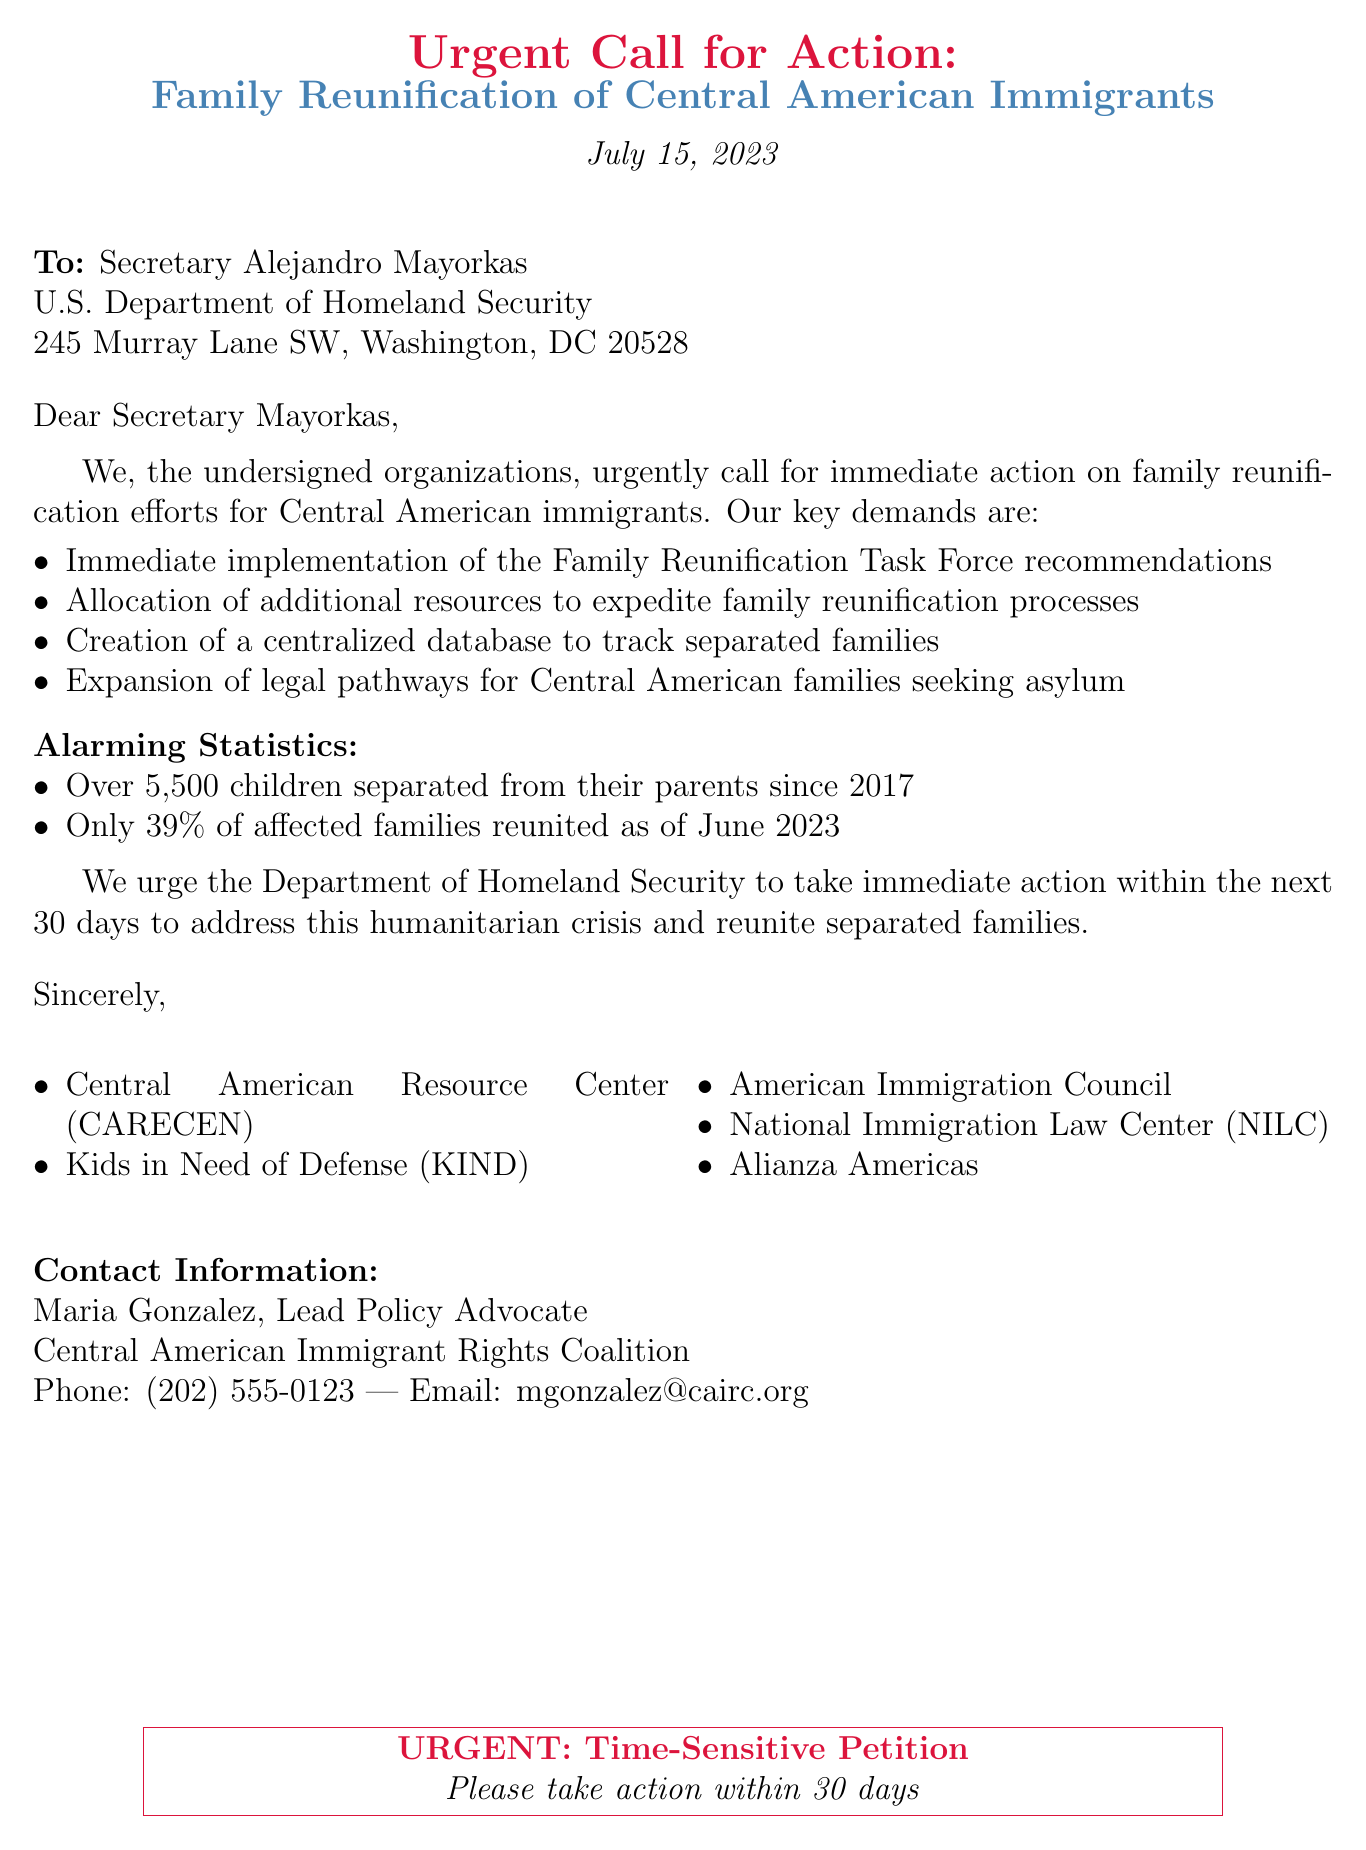What is the date of the petition? The date of the petition is indicated at the top of the document, which is July 15, 2023.
Answer: July 15, 2023 Who is the intended recipient of the petition? The document explicitly mentions the recipient as Secretary Alejandro Mayorkas, U.S. Department of Homeland Security.
Answer: Secretary Alejandro Mayorkas How many organizations signed the petition? The number of organizations signed can be counted from the list provided at the end of the document, which lists five organizations.
Answer: 5 What percentage of affected families were reunited as of June 2023? The document states that only 39% of affected families were reunited as of June 2023.
Answer: 39% What is one of the key demands of the petition? The petition outlines several key demands, one of which is the immediate implementation of the Family Reunification Task Force recommendations.
Answer: Immediate implementation of the Family Reunification Task Force recommendations What is the urgent action timeframe requested in the petition? The petition specifies that immediate action is urged within the next 30 days.
Answer: 30 days What alarming statistic is mentioned regarding separated children? The document provides a statistic on separated children, stating over 5,500 children were separated from their parents since 2017.
Answer: Over 5,500 children Who is the lead policy advocate mentioned in the document? The document lists Maria Gonzalez as the Lead Policy Advocate, Central American Immigrant Rights Coalition.
Answer: Maria Gonzalez 